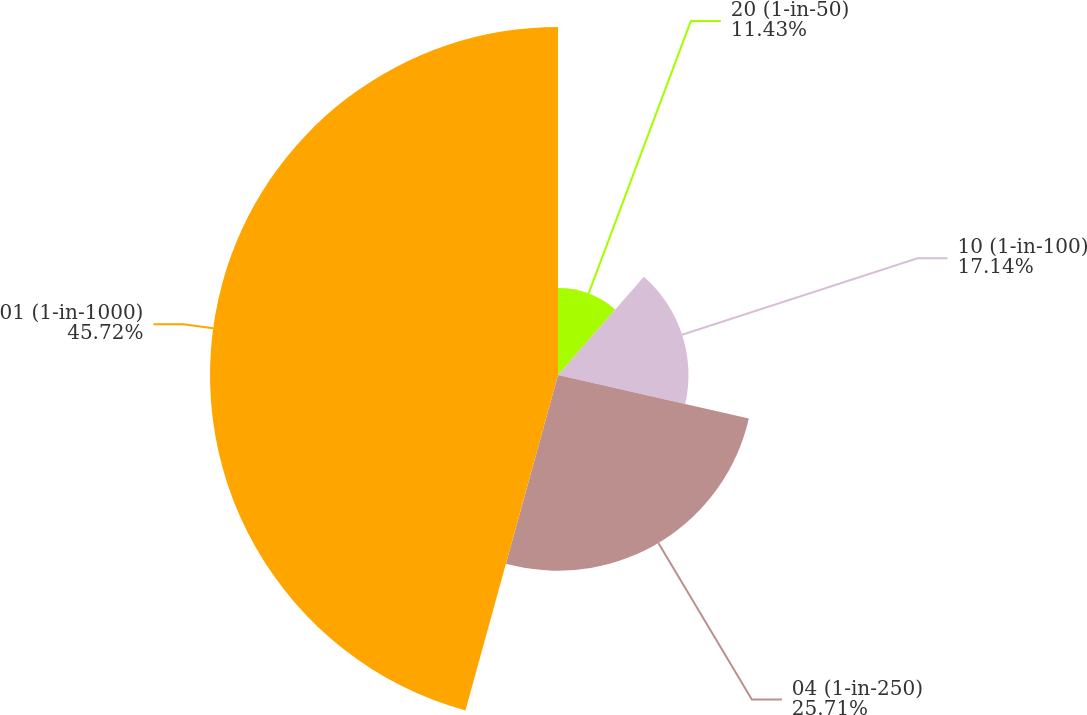Convert chart. <chart><loc_0><loc_0><loc_500><loc_500><pie_chart><fcel>20 (1-in-50)<fcel>10 (1-in-100)<fcel>04 (1-in-250)<fcel>01 (1-in-1000)<nl><fcel>11.43%<fcel>17.14%<fcel>25.71%<fcel>45.71%<nl></chart> 